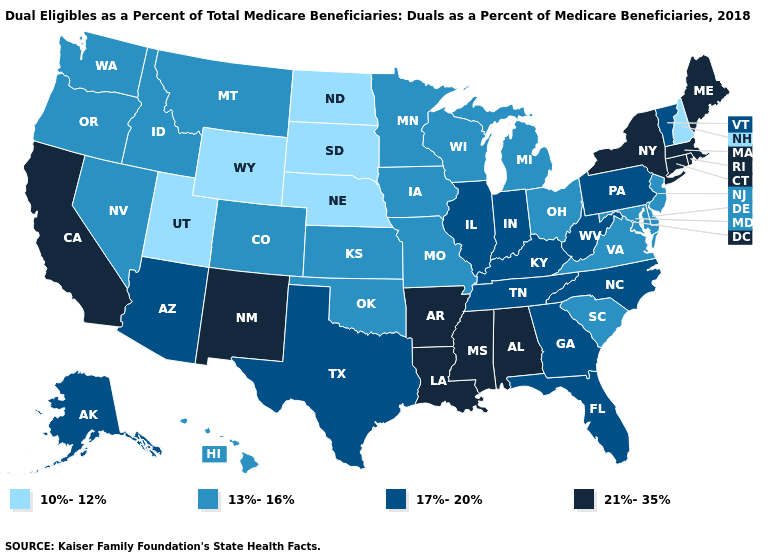How many symbols are there in the legend?
Write a very short answer. 4. What is the lowest value in the Northeast?
Concise answer only. 10%-12%. How many symbols are there in the legend?
Answer briefly. 4. What is the value of Montana?
Concise answer only. 13%-16%. Is the legend a continuous bar?
Give a very brief answer. No. Does South Dakota have the highest value in the USA?
Concise answer only. No. Name the states that have a value in the range 17%-20%?
Give a very brief answer. Alaska, Arizona, Florida, Georgia, Illinois, Indiana, Kentucky, North Carolina, Pennsylvania, Tennessee, Texas, Vermont, West Virginia. Does Tennessee have the same value as Rhode Island?
Short answer required. No. What is the highest value in the USA?
Concise answer only. 21%-35%. Which states hav the highest value in the Northeast?
Short answer required. Connecticut, Maine, Massachusetts, New York, Rhode Island. Name the states that have a value in the range 13%-16%?
Keep it brief. Colorado, Delaware, Hawaii, Idaho, Iowa, Kansas, Maryland, Michigan, Minnesota, Missouri, Montana, Nevada, New Jersey, Ohio, Oklahoma, Oregon, South Carolina, Virginia, Washington, Wisconsin. Name the states that have a value in the range 21%-35%?
Concise answer only. Alabama, Arkansas, California, Connecticut, Louisiana, Maine, Massachusetts, Mississippi, New Mexico, New York, Rhode Island. What is the value of Massachusetts?
Give a very brief answer. 21%-35%. Does Pennsylvania have the same value as Maryland?
Be succinct. No. Name the states that have a value in the range 13%-16%?
Answer briefly. Colorado, Delaware, Hawaii, Idaho, Iowa, Kansas, Maryland, Michigan, Minnesota, Missouri, Montana, Nevada, New Jersey, Ohio, Oklahoma, Oregon, South Carolina, Virginia, Washington, Wisconsin. 